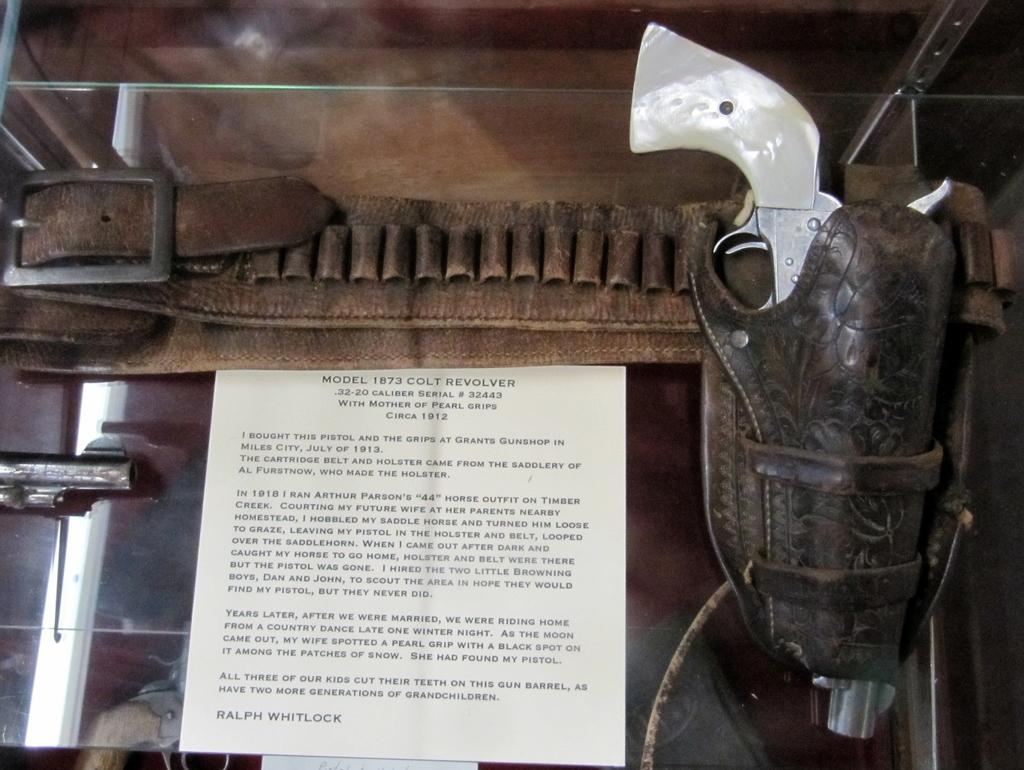What is written on the paper that is visible in the image? Unfortunately, the specific text on the paper cannot be determined from the provided facts. Besides the paper, what other item can be seen in the image? There is a belt visible in the image. What are the unspecified objects in the image? The unspecified objects in the image cannot be described in detail based on the provided facts. What type of mist can be seen surrounding the belt in the image? There is no mist present in the image; it only features a paper with text, a belt, and some unspecified objects. What type of quill is being used to write on the paper in the image? There is no quill visible in the image; it only features a paper with text, a belt, and some unspecified objects. 